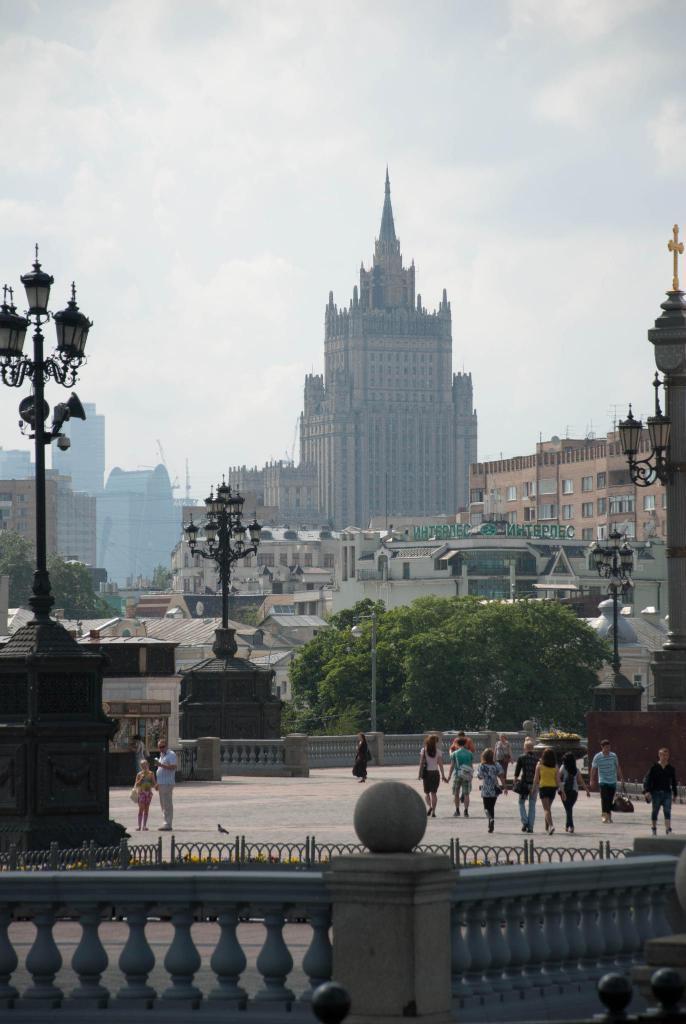Describe this image in one or two sentences. In this image we can see a few people walking on the floor, there are street lights, buildings, trees and sky on the top. 